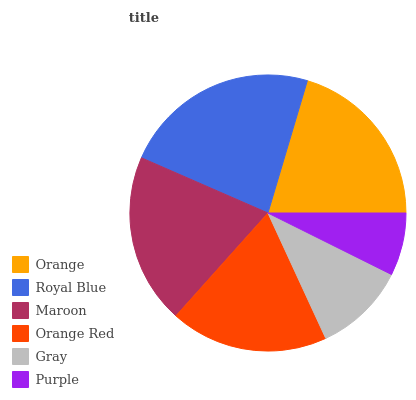Is Purple the minimum?
Answer yes or no. Yes. Is Royal Blue the maximum?
Answer yes or no. Yes. Is Maroon the minimum?
Answer yes or no. No. Is Maroon the maximum?
Answer yes or no. No. Is Royal Blue greater than Maroon?
Answer yes or no. Yes. Is Maroon less than Royal Blue?
Answer yes or no. Yes. Is Maroon greater than Royal Blue?
Answer yes or no. No. Is Royal Blue less than Maroon?
Answer yes or no. No. Is Maroon the high median?
Answer yes or no. Yes. Is Orange Red the low median?
Answer yes or no. Yes. Is Royal Blue the high median?
Answer yes or no. No. Is Purple the low median?
Answer yes or no. No. 